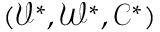Convert formula to latex. <formula><loc_0><loc_0><loc_500><loc_500>( \mathcal { V } ^ { * } , \mathcal { W } ^ { * } , \mathcal { C } ^ { * } )</formula> 